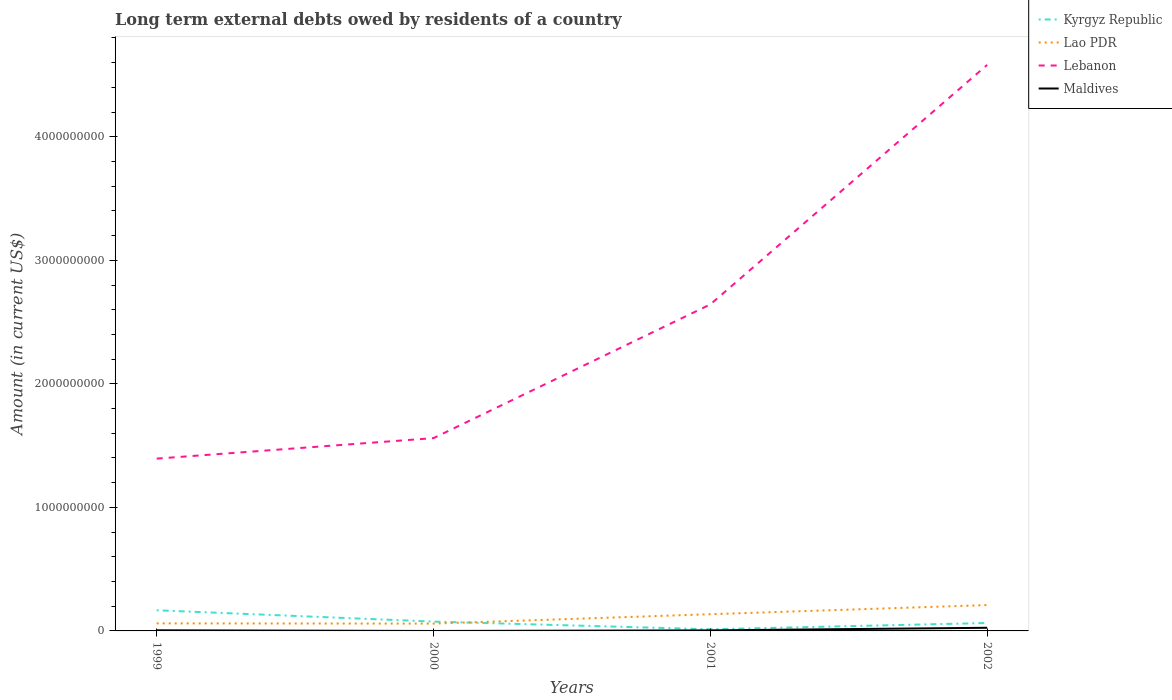Is the number of lines equal to the number of legend labels?
Your answer should be compact. No. Across all years, what is the maximum amount of long-term external debts owed by residents in Lebanon?
Keep it short and to the point. 1.39e+09. What is the total amount of long-term external debts owed by residents in Lebanon in the graph?
Offer a terse response. -1.25e+09. What is the difference between the highest and the second highest amount of long-term external debts owed by residents in Kyrgyz Republic?
Provide a succinct answer. 1.54e+08. What is the difference between the highest and the lowest amount of long-term external debts owed by residents in Maldives?
Make the answer very short. 1. Is the amount of long-term external debts owed by residents in Lao PDR strictly greater than the amount of long-term external debts owed by residents in Maldives over the years?
Provide a succinct answer. No. How many lines are there?
Ensure brevity in your answer.  4. Are the values on the major ticks of Y-axis written in scientific E-notation?
Your answer should be very brief. No. How many legend labels are there?
Provide a short and direct response. 4. How are the legend labels stacked?
Offer a terse response. Vertical. What is the title of the graph?
Ensure brevity in your answer.  Long term external debts owed by residents of a country. Does "Lower middle income" appear as one of the legend labels in the graph?
Offer a very short reply. No. What is the label or title of the X-axis?
Offer a very short reply. Years. What is the label or title of the Y-axis?
Your response must be concise. Amount (in current US$). What is the Amount (in current US$) in Kyrgyz Republic in 1999?
Offer a very short reply. 1.67e+08. What is the Amount (in current US$) of Lao PDR in 1999?
Keep it short and to the point. 6.11e+07. What is the Amount (in current US$) of Lebanon in 1999?
Keep it short and to the point. 1.39e+09. What is the Amount (in current US$) in Maldives in 1999?
Keep it short and to the point. 5.05e+06. What is the Amount (in current US$) in Kyrgyz Republic in 2000?
Keep it short and to the point. 7.54e+07. What is the Amount (in current US$) of Lao PDR in 2000?
Make the answer very short. 5.92e+07. What is the Amount (in current US$) in Lebanon in 2000?
Your response must be concise. 1.56e+09. What is the Amount (in current US$) of Kyrgyz Republic in 2001?
Your response must be concise. 1.33e+07. What is the Amount (in current US$) in Lao PDR in 2001?
Make the answer very short. 1.35e+08. What is the Amount (in current US$) in Lebanon in 2001?
Keep it short and to the point. 2.64e+09. What is the Amount (in current US$) in Maldives in 2001?
Offer a very short reply. 4.34e+06. What is the Amount (in current US$) in Kyrgyz Republic in 2002?
Provide a short and direct response. 6.41e+07. What is the Amount (in current US$) in Lao PDR in 2002?
Give a very brief answer. 2.09e+08. What is the Amount (in current US$) of Lebanon in 2002?
Ensure brevity in your answer.  4.58e+09. What is the Amount (in current US$) in Maldives in 2002?
Your response must be concise. 2.55e+07. Across all years, what is the maximum Amount (in current US$) of Kyrgyz Republic?
Provide a short and direct response. 1.67e+08. Across all years, what is the maximum Amount (in current US$) in Lao PDR?
Your answer should be compact. 2.09e+08. Across all years, what is the maximum Amount (in current US$) in Lebanon?
Your answer should be very brief. 4.58e+09. Across all years, what is the maximum Amount (in current US$) in Maldives?
Your answer should be compact. 2.55e+07. Across all years, what is the minimum Amount (in current US$) in Kyrgyz Republic?
Ensure brevity in your answer.  1.33e+07. Across all years, what is the minimum Amount (in current US$) in Lao PDR?
Your answer should be compact. 5.92e+07. Across all years, what is the minimum Amount (in current US$) of Lebanon?
Make the answer very short. 1.39e+09. Across all years, what is the minimum Amount (in current US$) of Maldives?
Keep it short and to the point. 0. What is the total Amount (in current US$) in Kyrgyz Republic in the graph?
Offer a terse response. 3.20e+08. What is the total Amount (in current US$) in Lao PDR in the graph?
Make the answer very short. 4.65e+08. What is the total Amount (in current US$) in Lebanon in the graph?
Ensure brevity in your answer.  1.02e+1. What is the total Amount (in current US$) in Maldives in the graph?
Offer a very short reply. 3.49e+07. What is the difference between the Amount (in current US$) of Kyrgyz Republic in 1999 and that in 2000?
Make the answer very short. 9.17e+07. What is the difference between the Amount (in current US$) of Lao PDR in 1999 and that in 2000?
Give a very brief answer. 1.89e+06. What is the difference between the Amount (in current US$) of Lebanon in 1999 and that in 2000?
Make the answer very short. -1.66e+08. What is the difference between the Amount (in current US$) of Kyrgyz Republic in 1999 and that in 2001?
Make the answer very short. 1.54e+08. What is the difference between the Amount (in current US$) in Lao PDR in 1999 and that in 2001?
Offer a very short reply. -7.42e+07. What is the difference between the Amount (in current US$) of Lebanon in 1999 and that in 2001?
Provide a succinct answer. -1.25e+09. What is the difference between the Amount (in current US$) in Maldives in 1999 and that in 2001?
Keep it short and to the point. 7.08e+05. What is the difference between the Amount (in current US$) in Kyrgyz Republic in 1999 and that in 2002?
Your response must be concise. 1.03e+08. What is the difference between the Amount (in current US$) in Lao PDR in 1999 and that in 2002?
Your answer should be very brief. -1.48e+08. What is the difference between the Amount (in current US$) of Lebanon in 1999 and that in 2002?
Your response must be concise. -3.19e+09. What is the difference between the Amount (in current US$) in Maldives in 1999 and that in 2002?
Your answer should be very brief. -2.04e+07. What is the difference between the Amount (in current US$) of Kyrgyz Republic in 2000 and that in 2001?
Your answer should be compact. 6.21e+07. What is the difference between the Amount (in current US$) in Lao PDR in 2000 and that in 2001?
Your response must be concise. -7.61e+07. What is the difference between the Amount (in current US$) in Lebanon in 2000 and that in 2001?
Offer a terse response. -1.08e+09. What is the difference between the Amount (in current US$) of Kyrgyz Republic in 2000 and that in 2002?
Your answer should be very brief. 1.14e+07. What is the difference between the Amount (in current US$) in Lao PDR in 2000 and that in 2002?
Your answer should be very brief. -1.50e+08. What is the difference between the Amount (in current US$) of Lebanon in 2000 and that in 2002?
Offer a terse response. -3.02e+09. What is the difference between the Amount (in current US$) in Kyrgyz Republic in 2001 and that in 2002?
Your answer should be very brief. -5.07e+07. What is the difference between the Amount (in current US$) in Lao PDR in 2001 and that in 2002?
Your response must be concise. -7.41e+07. What is the difference between the Amount (in current US$) in Lebanon in 2001 and that in 2002?
Make the answer very short. -1.94e+09. What is the difference between the Amount (in current US$) in Maldives in 2001 and that in 2002?
Keep it short and to the point. -2.11e+07. What is the difference between the Amount (in current US$) of Kyrgyz Republic in 1999 and the Amount (in current US$) of Lao PDR in 2000?
Give a very brief answer. 1.08e+08. What is the difference between the Amount (in current US$) in Kyrgyz Republic in 1999 and the Amount (in current US$) in Lebanon in 2000?
Make the answer very short. -1.39e+09. What is the difference between the Amount (in current US$) in Lao PDR in 1999 and the Amount (in current US$) in Lebanon in 2000?
Give a very brief answer. -1.50e+09. What is the difference between the Amount (in current US$) of Kyrgyz Republic in 1999 and the Amount (in current US$) of Lao PDR in 2001?
Provide a short and direct response. 3.18e+07. What is the difference between the Amount (in current US$) of Kyrgyz Republic in 1999 and the Amount (in current US$) of Lebanon in 2001?
Your answer should be compact. -2.48e+09. What is the difference between the Amount (in current US$) of Kyrgyz Republic in 1999 and the Amount (in current US$) of Maldives in 2001?
Offer a very short reply. 1.63e+08. What is the difference between the Amount (in current US$) in Lao PDR in 1999 and the Amount (in current US$) in Lebanon in 2001?
Make the answer very short. -2.58e+09. What is the difference between the Amount (in current US$) in Lao PDR in 1999 and the Amount (in current US$) in Maldives in 2001?
Provide a short and direct response. 5.68e+07. What is the difference between the Amount (in current US$) in Lebanon in 1999 and the Amount (in current US$) in Maldives in 2001?
Make the answer very short. 1.39e+09. What is the difference between the Amount (in current US$) of Kyrgyz Republic in 1999 and the Amount (in current US$) of Lao PDR in 2002?
Offer a terse response. -4.23e+07. What is the difference between the Amount (in current US$) in Kyrgyz Republic in 1999 and the Amount (in current US$) in Lebanon in 2002?
Provide a succinct answer. -4.42e+09. What is the difference between the Amount (in current US$) of Kyrgyz Republic in 1999 and the Amount (in current US$) of Maldives in 2002?
Offer a terse response. 1.42e+08. What is the difference between the Amount (in current US$) in Lao PDR in 1999 and the Amount (in current US$) in Lebanon in 2002?
Offer a terse response. -4.52e+09. What is the difference between the Amount (in current US$) of Lao PDR in 1999 and the Amount (in current US$) of Maldives in 2002?
Your answer should be very brief. 3.57e+07. What is the difference between the Amount (in current US$) in Lebanon in 1999 and the Amount (in current US$) in Maldives in 2002?
Provide a succinct answer. 1.37e+09. What is the difference between the Amount (in current US$) of Kyrgyz Republic in 2000 and the Amount (in current US$) of Lao PDR in 2001?
Ensure brevity in your answer.  -5.99e+07. What is the difference between the Amount (in current US$) in Kyrgyz Republic in 2000 and the Amount (in current US$) in Lebanon in 2001?
Make the answer very short. -2.57e+09. What is the difference between the Amount (in current US$) in Kyrgyz Republic in 2000 and the Amount (in current US$) in Maldives in 2001?
Provide a short and direct response. 7.11e+07. What is the difference between the Amount (in current US$) of Lao PDR in 2000 and the Amount (in current US$) of Lebanon in 2001?
Your answer should be compact. -2.58e+09. What is the difference between the Amount (in current US$) of Lao PDR in 2000 and the Amount (in current US$) of Maldives in 2001?
Give a very brief answer. 5.49e+07. What is the difference between the Amount (in current US$) of Lebanon in 2000 and the Amount (in current US$) of Maldives in 2001?
Provide a succinct answer. 1.56e+09. What is the difference between the Amount (in current US$) of Kyrgyz Republic in 2000 and the Amount (in current US$) of Lao PDR in 2002?
Keep it short and to the point. -1.34e+08. What is the difference between the Amount (in current US$) of Kyrgyz Republic in 2000 and the Amount (in current US$) of Lebanon in 2002?
Offer a very short reply. -4.51e+09. What is the difference between the Amount (in current US$) of Kyrgyz Republic in 2000 and the Amount (in current US$) of Maldives in 2002?
Your response must be concise. 5.00e+07. What is the difference between the Amount (in current US$) in Lao PDR in 2000 and the Amount (in current US$) in Lebanon in 2002?
Provide a short and direct response. -4.52e+09. What is the difference between the Amount (in current US$) in Lao PDR in 2000 and the Amount (in current US$) in Maldives in 2002?
Make the answer very short. 3.38e+07. What is the difference between the Amount (in current US$) in Lebanon in 2000 and the Amount (in current US$) in Maldives in 2002?
Provide a succinct answer. 1.54e+09. What is the difference between the Amount (in current US$) of Kyrgyz Republic in 2001 and the Amount (in current US$) of Lao PDR in 2002?
Ensure brevity in your answer.  -1.96e+08. What is the difference between the Amount (in current US$) of Kyrgyz Republic in 2001 and the Amount (in current US$) of Lebanon in 2002?
Ensure brevity in your answer.  -4.57e+09. What is the difference between the Amount (in current US$) of Kyrgyz Republic in 2001 and the Amount (in current US$) of Maldives in 2002?
Provide a short and direct response. -1.22e+07. What is the difference between the Amount (in current US$) of Lao PDR in 2001 and the Amount (in current US$) of Lebanon in 2002?
Offer a very short reply. -4.45e+09. What is the difference between the Amount (in current US$) of Lao PDR in 2001 and the Amount (in current US$) of Maldives in 2002?
Keep it short and to the point. 1.10e+08. What is the difference between the Amount (in current US$) of Lebanon in 2001 and the Amount (in current US$) of Maldives in 2002?
Your answer should be very brief. 2.62e+09. What is the average Amount (in current US$) in Kyrgyz Republic per year?
Your response must be concise. 8.00e+07. What is the average Amount (in current US$) of Lao PDR per year?
Offer a terse response. 1.16e+08. What is the average Amount (in current US$) in Lebanon per year?
Keep it short and to the point. 2.55e+09. What is the average Amount (in current US$) in Maldives per year?
Your answer should be compact. 8.71e+06. In the year 1999, what is the difference between the Amount (in current US$) of Kyrgyz Republic and Amount (in current US$) of Lao PDR?
Keep it short and to the point. 1.06e+08. In the year 1999, what is the difference between the Amount (in current US$) in Kyrgyz Republic and Amount (in current US$) in Lebanon?
Your response must be concise. -1.23e+09. In the year 1999, what is the difference between the Amount (in current US$) in Kyrgyz Republic and Amount (in current US$) in Maldives?
Your response must be concise. 1.62e+08. In the year 1999, what is the difference between the Amount (in current US$) in Lao PDR and Amount (in current US$) in Lebanon?
Your answer should be compact. -1.33e+09. In the year 1999, what is the difference between the Amount (in current US$) of Lao PDR and Amount (in current US$) of Maldives?
Your answer should be very brief. 5.61e+07. In the year 1999, what is the difference between the Amount (in current US$) of Lebanon and Amount (in current US$) of Maldives?
Your answer should be very brief. 1.39e+09. In the year 2000, what is the difference between the Amount (in current US$) of Kyrgyz Republic and Amount (in current US$) of Lao PDR?
Provide a succinct answer. 1.62e+07. In the year 2000, what is the difference between the Amount (in current US$) in Kyrgyz Republic and Amount (in current US$) in Lebanon?
Your answer should be very brief. -1.49e+09. In the year 2000, what is the difference between the Amount (in current US$) of Lao PDR and Amount (in current US$) of Lebanon?
Provide a succinct answer. -1.50e+09. In the year 2001, what is the difference between the Amount (in current US$) of Kyrgyz Republic and Amount (in current US$) of Lao PDR?
Keep it short and to the point. -1.22e+08. In the year 2001, what is the difference between the Amount (in current US$) in Kyrgyz Republic and Amount (in current US$) in Lebanon?
Keep it short and to the point. -2.63e+09. In the year 2001, what is the difference between the Amount (in current US$) in Kyrgyz Republic and Amount (in current US$) in Maldives?
Provide a succinct answer. 8.96e+06. In the year 2001, what is the difference between the Amount (in current US$) in Lao PDR and Amount (in current US$) in Lebanon?
Provide a short and direct response. -2.51e+09. In the year 2001, what is the difference between the Amount (in current US$) in Lao PDR and Amount (in current US$) in Maldives?
Give a very brief answer. 1.31e+08. In the year 2001, what is the difference between the Amount (in current US$) of Lebanon and Amount (in current US$) of Maldives?
Your answer should be compact. 2.64e+09. In the year 2002, what is the difference between the Amount (in current US$) of Kyrgyz Republic and Amount (in current US$) of Lao PDR?
Your response must be concise. -1.45e+08. In the year 2002, what is the difference between the Amount (in current US$) in Kyrgyz Republic and Amount (in current US$) in Lebanon?
Your answer should be very brief. -4.52e+09. In the year 2002, what is the difference between the Amount (in current US$) in Kyrgyz Republic and Amount (in current US$) in Maldives?
Your response must be concise. 3.86e+07. In the year 2002, what is the difference between the Amount (in current US$) in Lao PDR and Amount (in current US$) in Lebanon?
Your response must be concise. -4.37e+09. In the year 2002, what is the difference between the Amount (in current US$) in Lao PDR and Amount (in current US$) in Maldives?
Your answer should be very brief. 1.84e+08. In the year 2002, what is the difference between the Amount (in current US$) of Lebanon and Amount (in current US$) of Maldives?
Offer a very short reply. 4.56e+09. What is the ratio of the Amount (in current US$) of Kyrgyz Republic in 1999 to that in 2000?
Your response must be concise. 2.21. What is the ratio of the Amount (in current US$) of Lao PDR in 1999 to that in 2000?
Your response must be concise. 1.03. What is the ratio of the Amount (in current US$) in Lebanon in 1999 to that in 2000?
Offer a very short reply. 0.89. What is the ratio of the Amount (in current US$) in Kyrgyz Republic in 1999 to that in 2001?
Your answer should be very brief. 12.56. What is the ratio of the Amount (in current US$) of Lao PDR in 1999 to that in 2001?
Keep it short and to the point. 0.45. What is the ratio of the Amount (in current US$) of Lebanon in 1999 to that in 2001?
Give a very brief answer. 0.53. What is the ratio of the Amount (in current US$) in Maldives in 1999 to that in 2001?
Offer a terse response. 1.16. What is the ratio of the Amount (in current US$) in Kyrgyz Republic in 1999 to that in 2002?
Provide a succinct answer. 2.61. What is the ratio of the Amount (in current US$) of Lao PDR in 1999 to that in 2002?
Keep it short and to the point. 0.29. What is the ratio of the Amount (in current US$) in Lebanon in 1999 to that in 2002?
Your answer should be very brief. 0.3. What is the ratio of the Amount (in current US$) of Maldives in 1999 to that in 2002?
Offer a very short reply. 0.2. What is the ratio of the Amount (in current US$) of Kyrgyz Republic in 2000 to that in 2001?
Your answer should be compact. 5.67. What is the ratio of the Amount (in current US$) in Lao PDR in 2000 to that in 2001?
Provide a succinct answer. 0.44. What is the ratio of the Amount (in current US$) in Lebanon in 2000 to that in 2001?
Offer a terse response. 0.59. What is the ratio of the Amount (in current US$) of Kyrgyz Republic in 2000 to that in 2002?
Your answer should be compact. 1.18. What is the ratio of the Amount (in current US$) of Lao PDR in 2000 to that in 2002?
Keep it short and to the point. 0.28. What is the ratio of the Amount (in current US$) in Lebanon in 2000 to that in 2002?
Give a very brief answer. 0.34. What is the ratio of the Amount (in current US$) in Kyrgyz Republic in 2001 to that in 2002?
Your response must be concise. 0.21. What is the ratio of the Amount (in current US$) in Lao PDR in 2001 to that in 2002?
Your answer should be compact. 0.65. What is the ratio of the Amount (in current US$) of Lebanon in 2001 to that in 2002?
Give a very brief answer. 0.58. What is the ratio of the Amount (in current US$) in Maldives in 2001 to that in 2002?
Offer a very short reply. 0.17. What is the difference between the highest and the second highest Amount (in current US$) of Kyrgyz Republic?
Keep it short and to the point. 9.17e+07. What is the difference between the highest and the second highest Amount (in current US$) of Lao PDR?
Your answer should be very brief. 7.41e+07. What is the difference between the highest and the second highest Amount (in current US$) of Lebanon?
Your response must be concise. 1.94e+09. What is the difference between the highest and the second highest Amount (in current US$) of Maldives?
Provide a short and direct response. 2.04e+07. What is the difference between the highest and the lowest Amount (in current US$) of Kyrgyz Republic?
Your answer should be compact. 1.54e+08. What is the difference between the highest and the lowest Amount (in current US$) in Lao PDR?
Offer a terse response. 1.50e+08. What is the difference between the highest and the lowest Amount (in current US$) in Lebanon?
Offer a very short reply. 3.19e+09. What is the difference between the highest and the lowest Amount (in current US$) of Maldives?
Keep it short and to the point. 2.55e+07. 